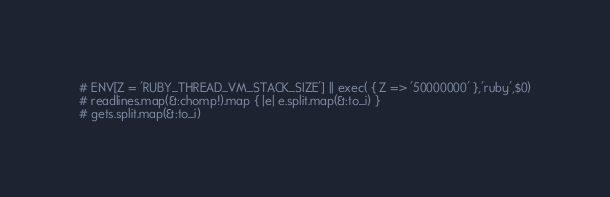<code> <loc_0><loc_0><loc_500><loc_500><_Ruby_># ENV[Z = 'RUBY_THREAD_VM_STACK_SIZE'] || exec( { Z => '50000000' },'ruby',$0)
# readlines.map(&:chomp!).map { |e| e.split.map(&:to_i) }
# gets.split.map(&:to_i)
</code> 